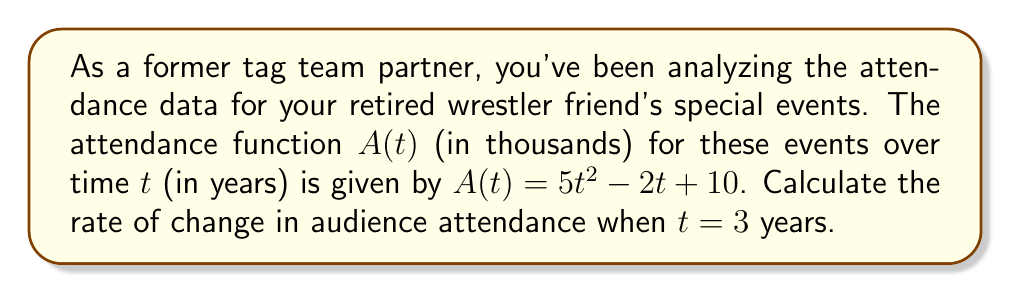Can you answer this question? To find the rate of change in audience attendance at a specific point in time, we need to calculate the derivative of the attendance function $A(t)$ and then evaluate it at $t = 3$.

Step 1: Find the derivative of $A(t)$
$$A(t) = 5t^2 - 2t + 10$$
$$A'(t) = 10t - 2$$

Step 2: Evaluate $A'(t)$ at $t = 3$
$$A'(3) = 10(3) - 2$$
$$A'(3) = 30 - 2 = 28$$

The rate of change is measured in thousands of attendees per year, so we need to interpret our result accordingly.
Answer: 28,000 attendees per year 